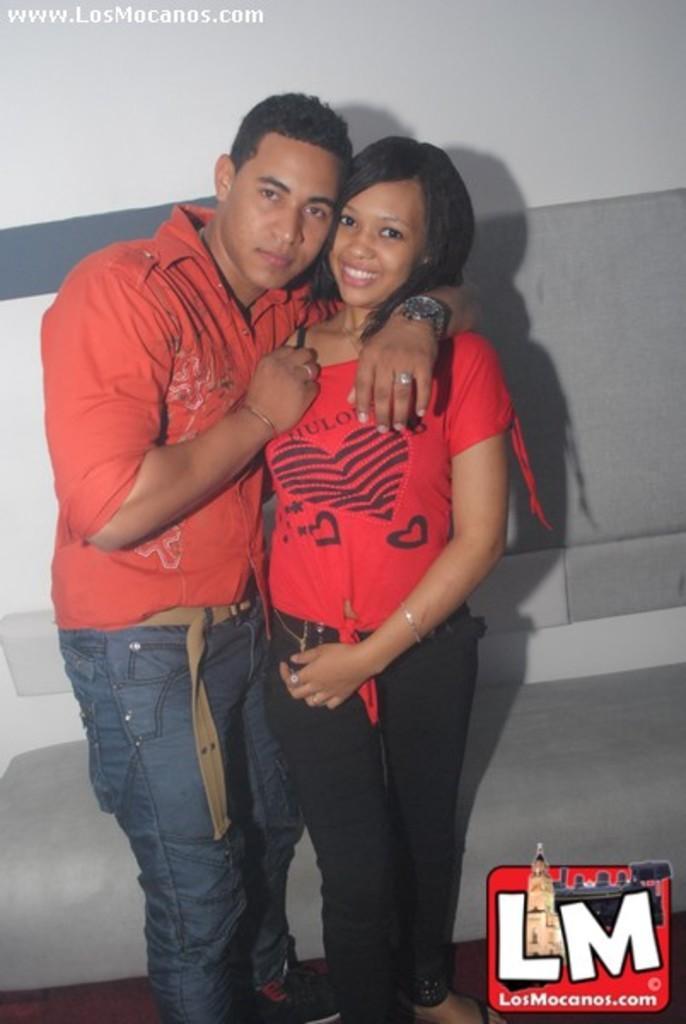Describe this image in one or two sentences. In the image we can see a man and a woman standing, they are wearing clothes. The man is wearing a wrist watch and a finger ring, this is a bracelet, watermark, wall and a floor. 